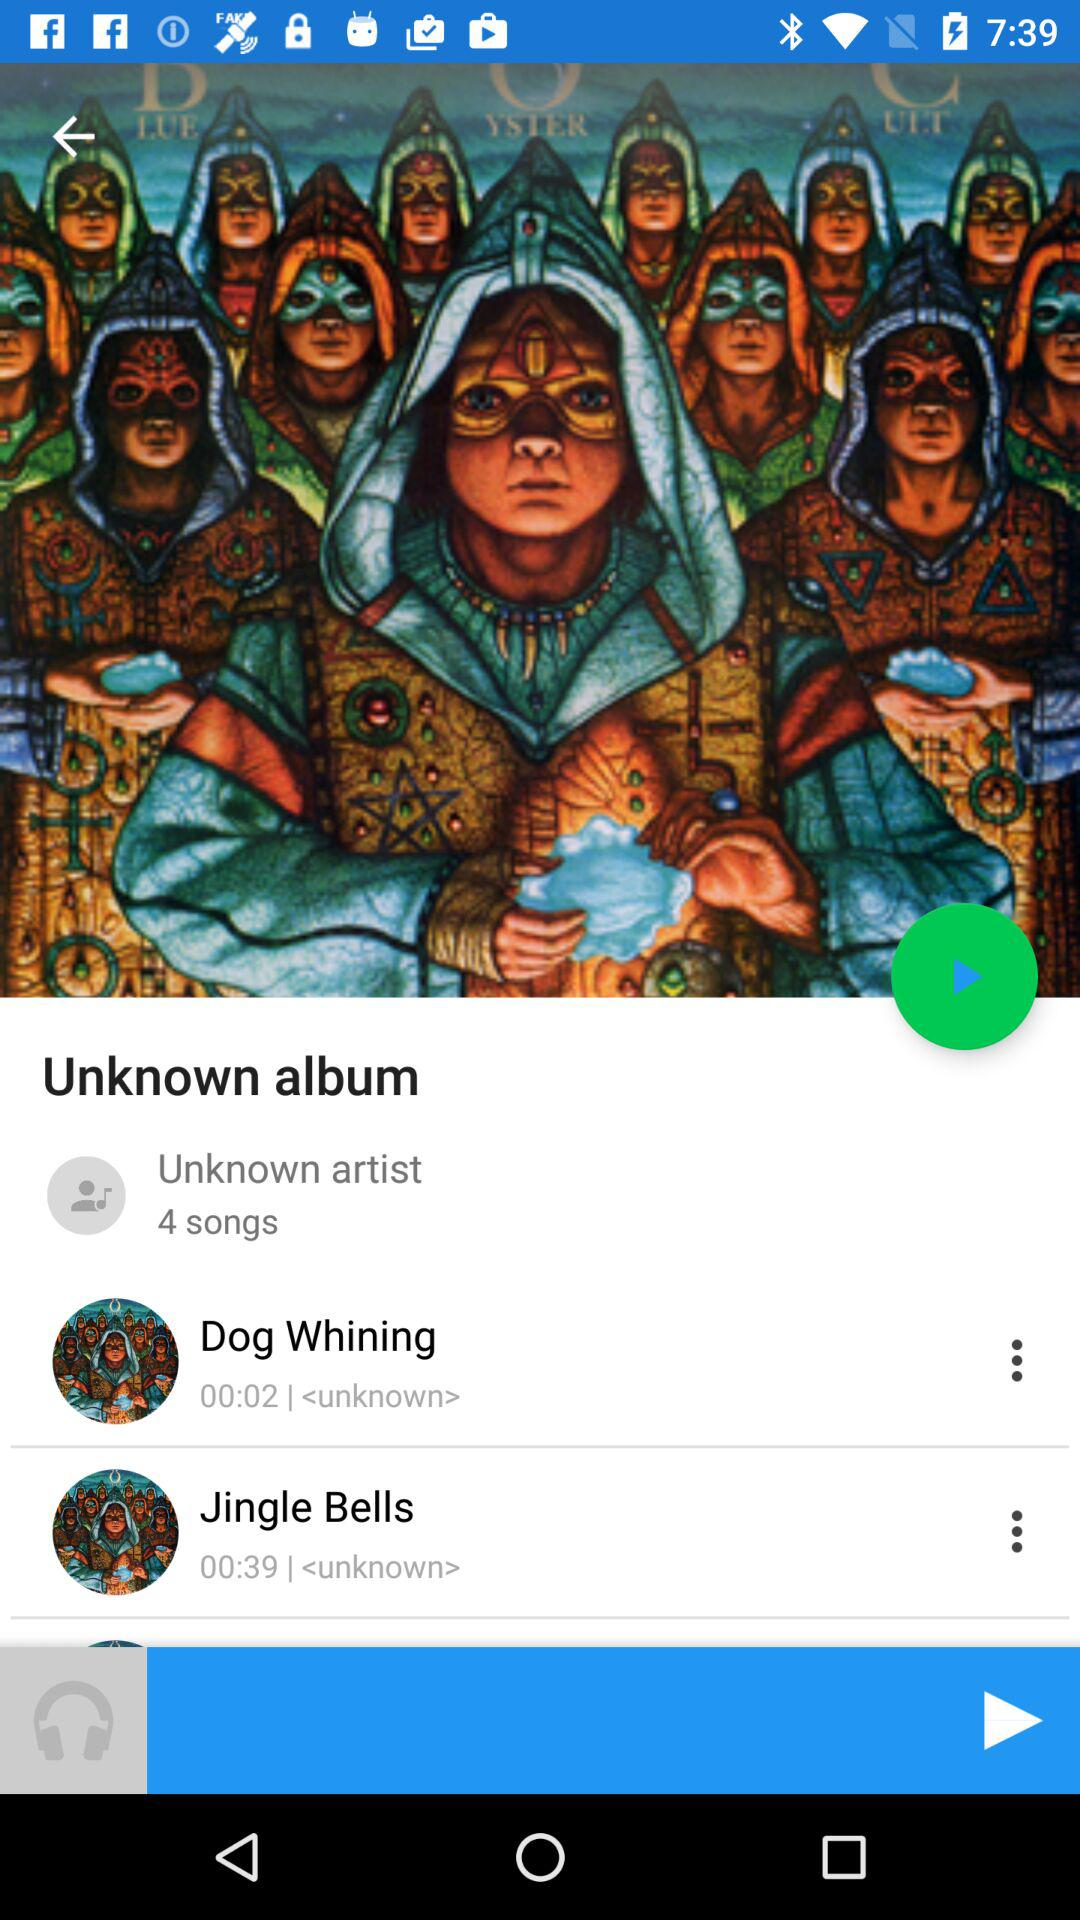How many songs are in the album?
Answer the question using a single word or phrase. 4 